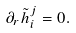<formula> <loc_0><loc_0><loc_500><loc_500>\partial _ { r } \tilde { h } _ { i } ^ { j } = 0 .</formula> 